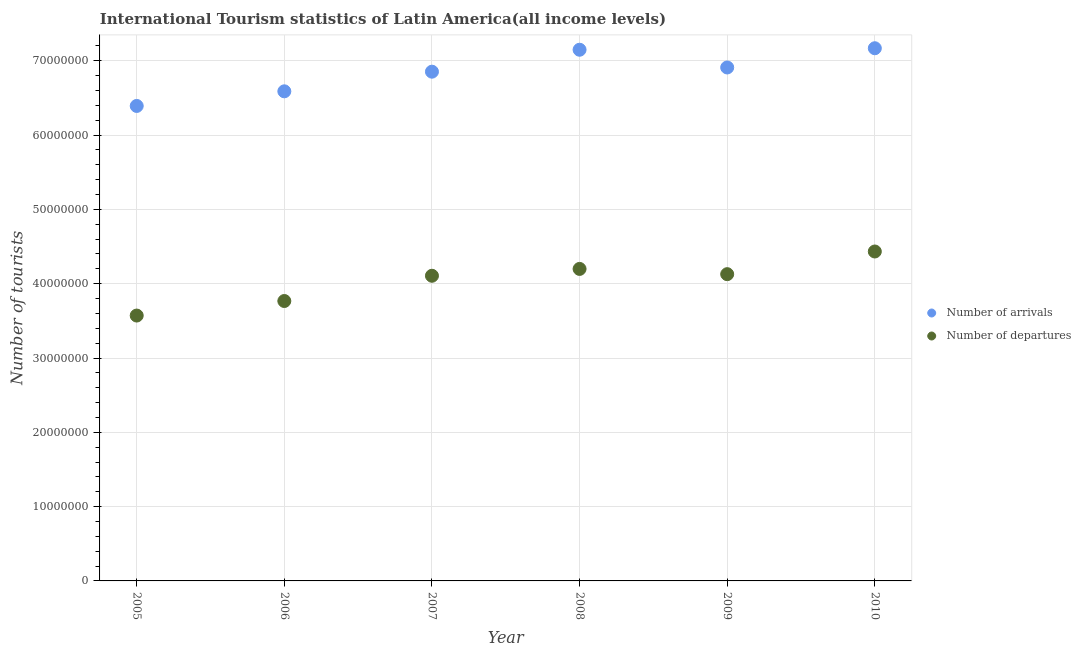How many different coloured dotlines are there?
Keep it short and to the point. 2. What is the number of tourist arrivals in 2009?
Give a very brief answer. 6.91e+07. Across all years, what is the maximum number of tourist departures?
Your answer should be very brief. 4.43e+07. Across all years, what is the minimum number of tourist arrivals?
Your answer should be very brief. 6.39e+07. What is the total number of tourist departures in the graph?
Make the answer very short. 2.42e+08. What is the difference between the number of tourist departures in 2009 and that in 2010?
Make the answer very short. -3.05e+06. What is the difference between the number of tourist departures in 2007 and the number of tourist arrivals in 2008?
Ensure brevity in your answer.  -3.04e+07. What is the average number of tourist departures per year?
Your response must be concise. 4.03e+07. In the year 2005, what is the difference between the number of tourist departures and number of tourist arrivals?
Keep it short and to the point. -2.82e+07. What is the ratio of the number of tourist arrivals in 2006 to that in 2010?
Give a very brief answer. 0.92. Is the number of tourist departures in 2007 less than that in 2008?
Offer a terse response. Yes. Is the difference between the number of tourist departures in 2007 and 2010 greater than the difference between the number of tourist arrivals in 2007 and 2010?
Give a very brief answer. No. What is the difference between the highest and the second highest number of tourist departures?
Keep it short and to the point. 2.34e+06. What is the difference between the highest and the lowest number of tourist arrivals?
Provide a short and direct response. 7.77e+06. In how many years, is the number of tourist arrivals greater than the average number of tourist arrivals taken over all years?
Ensure brevity in your answer.  4. Is the number of tourist arrivals strictly greater than the number of tourist departures over the years?
Provide a succinct answer. Yes. How many years are there in the graph?
Offer a terse response. 6. What is the difference between two consecutive major ticks on the Y-axis?
Offer a terse response. 1.00e+07. Does the graph contain any zero values?
Provide a short and direct response. No. Does the graph contain grids?
Your answer should be compact. Yes. Where does the legend appear in the graph?
Keep it short and to the point. Center right. What is the title of the graph?
Your response must be concise. International Tourism statistics of Latin America(all income levels). Does "Nitrous oxide emissions" appear as one of the legend labels in the graph?
Provide a short and direct response. No. What is the label or title of the Y-axis?
Your response must be concise. Number of tourists. What is the Number of tourists in Number of arrivals in 2005?
Ensure brevity in your answer.  6.39e+07. What is the Number of tourists in Number of departures in 2005?
Your response must be concise. 3.57e+07. What is the Number of tourists in Number of arrivals in 2006?
Your answer should be very brief. 6.59e+07. What is the Number of tourists in Number of departures in 2006?
Make the answer very short. 3.77e+07. What is the Number of tourists of Number of arrivals in 2007?
Offer a very short reply. 6.85e+07. What is the Number of tourists in Number of departures in 2007?
Provide a succinct answer. 4.11e+07. What is the Number of tourists in Number of arrivals in 2008?
Your answer should be very brief. 7.15e+07. What is the Number of tourists in Number of departures in 2008?
Your response must be concise. 4.20e+07. What is the Number of tourists of Number of arrivals in 2009?
Give a very brief answer. 6.91e+07. What is the Number of tourists in Number of departures in 2009?
Ensure brevity in your answer.  4.13e+07. What is the Number of tourists in Number of arrivals in 2010?
Your answer should be compact. 7.17e+07. What is the Number of tourists in Number of departures in 2010?
Offer a terse response. 4.43e+07. Across all years, what is the maximum Number of tourists in Number of arrivals?
Give a very brief answer. 7.17e+07. Across all years, what is the maximum Number of tourists in Number of departures?
Provide a succinct answer. 4.43e+07. Across all years, what is the minimum Number of tourists in Number of arrivals?
Your response must be concise. 6.39e+07. Across all years, what is the minimum Number of tourists in Number of departures?
Your answer should be very brief. 3.57e+07. What is the total Number of tourists of Number of arrivals in the graph?
Provide a succinct answer. 4.11e+08. What is the total Number of tourists of Number of departures in the graph?
Your answer should be very brief. 2.42e+08. What is the difference between the Number of tourists in Number of arrivals in 2005 and that in 2006?
Offer a very short reply. -1.97e+06. What is the difference between the Number of tourists of Number of departures in 2005 and that in 2006?
Keep it short and to the point. -1.96e+06. What is the difference between the Number of tourists of Number of arrivals in 2005 and that in 2007?
Offer a very short reply. -4.61e+06. What is the difference between the Number of tourists in Number of departures in 2005 and that in 2007?
Your answer should be compact. -5.35e+06. What is the difference between the Number of tourists in Number of arrivals in 2005 and that in 2008?
Provide a succinct answer. -7.56e+06. What is the difference between the Number of tourists in Number of departures in 2005 and that in 2008?
Offer a terse response. -6.28e+06. What is the difference between the Number of tourists in Number of arrivals in 2005 and that in 2009?
Your answer should be compact. -5.18e+06. What is the difference between the Number of tourists of Number of departures in 2005 and that in 2009?
Provide a short and direct response. -5.57e+06. What is the difference between the Number of tourists of Number of arrivals in 2005 and that in 2010?
Your answer should be very brief. -7.77e+06. What is the difference between the Number of tourists of Number of departures in 2005 and that in 2010?
Give a very brief answer. -8.62e+06. What is the difference between the Number of tourists in Number of arrivals in 2006 and that in 2007?
Offer a very short reply. -2.64e+06. What is the difference between the Number of tourists of Number of departures in 2006 and that in 2007?
Provide a short and direct response. -3.40e+06. What is the difference between the Number of tourists of Number of arrivals in 2006 and that in 2008?
Your response must be concise. -5.59e+06. What is the difference between the Number of tourists in Number of departures in 2006 and that in 2008?
Your answer should be very brief. -4.32e+06. What is the difference between the Number of tourists in Number of arrivals in 2006 and that in 2009?
Your answer should be very brief. -3.21e+06. What is the difference between the Number of tourists in Number of departures in 2006 and that in 2009?
Provide a succinct answer. -3.61e+06. What is the difference between the Number of tourists of Number of arrivals in 2006 and that in 2010?
Your answer should be compact. -5.80e+06. What is the difference between the Number of tourists in Number of departures in 2006 and that in 2010?
Your answer should be very brief. -6.66e+06. What is the difference between the Number of tourists of Number of arrivals in 2007 and that in 2008?
Make the answer very short. -2.95e+06. What is the difference between the Number of tourists of Number of departures in 2007 and that in 2008?
Provide a short and direct response. -9.22e+05. What is the difference between the Number of tourists in Number of arrivals in 2007 and that in 2009?
Provide a succinct answer. -5.66e+05. What is the difference between the Number of tourists of Number of departures in 2007 and that in 2009?
Ensure brevity in your answer.  -2.15e+05. What is the difference between the Number of tourists of Number of arrivals in 2007 and that in 2010?
Provide a succinct answer. -3.15e+06. What is the difference between the Number of tourists of Number of departures in 2007 and that in 2010?
Provide a short and direct response. -3.27e+06. What is the difference between the Number of tourists in Number of arrivals in 2008 and that in 2009?
Make the answer very short. 2.39e+06. What is the difference between the Number of tourists of Number of departures in 2008 and that in 2009?
Keep it short and to the point. 7.06e+05. What is the difference between the Number of tourists in Number of arrivals in 2008 and that in 2010?
Your response must be concise. -2.02e+05. What is the difference between the Number of tourists in Number of departures in 2008 and that in 2010?
Your answer should be very brief. -2.34e+06. What is the difference between the Number of tourists of Number of arrivals in 2009 and that in 2010?
Offer a very short reply. -2.59e+06. What is the difference between the Number of tourists in Number of departures in 2009 and that in 2010?
Keep it short and to the point. -3.05e+06. What is the difference between the Number of tourists of Number of arrivals in 2005 and the Number of tourists of Number of departures in 2006?
Offer a terse response. 2.63e+07. What is the difference between the Number of tourists in Number of arrivals in 2005 and the Number of tourists in Number of departures in 2007?
Give a very brief answer. 2.29e+07. What is the difference between the Number of tourists in Number of arrivals in 2005 and the Number of tourists in Number of departures in 2008?
Offer a terse response. 2.19e+07. What is the difference between the Number of tourists in Number of arrivals in 2005 and the Number of tourists in Number of departures in 2009?
Ensure brevity in your answer.  2.26e+07. What is the difference between the Number of tourists of Number of arrivals in 2005 and the Number of tourists of Number of departures in 2010?
Your answer should be very brief. 1.96e+07. What is the difference between the Number of tourists of Number of arrivals in 2006 and the Number of tourists of Number of departures in 2007?
Your answer should be very brief. 2.48e+07. What is the difference between the Number of tourists in Number of arrivals in 2006 and the Number of tourists in Number of departures in 2008?
Your response must be concise. 2.39e+07. What is the difference between the Number of tourists in Number of arrivals in 2006 and the Number of tourists in Number of departures in 2009?
Make the answer very short. 2.46e+07. What is the difference between the Number of tourists in Number of arrivals in 2006 and the Number of tourists in Number of departures in 2010?
Ensure brevity in your answer.  2.16e+07. What is the difference between the Number of tourists of Number of arrivals in 2007 and the Number of tourists of Number of departures in 2008?
Give a very brief answer. 2.65e+07. What is the difference between the Number of tourists of Number of arrivals in 2007 and the Number of tourists of Number of departures in 2009?
Your answer should be very brief. 2.73e+07. What is the difference between the Number of tourists in Number of arrivals in 2007 and the Number of tourists in Number of departures in 2010?
Keep it short and to the point. 2.42e+07. What is the difference between the Number of tourists of Number of arrivals in 2008 and the Number of tourists of Number of departures in 2009?
Ensure brevity in your answer.  3.02e+07. What is the difference between the Number of tourists in Number of arrivals in 2008 and the Number of tourists in Number of departures in 2010?
Provide a succinct answer. 2.72e+07. What is the difference between the Number of tourists in Number of arrivals in 2009 and the Number of tourists in Number of departures in 2010?
Provide a short and direct response. 2.48e+07. What is the average Number of tourists of Number of arrivals per year?
Offer a very short reply. 6.84e+07. What is the average Number of tourists in Number of departures per year?
Provide a succinct answer. 4.03e+07. In the year 2005, what is the difference between the Number of tourists in Number of arrivals and Number of tourists in Number of departures?
Your answer should be very brief. 2.82e+07. In the year 2006, what is the difference between the Number of tourists of Number of arrivals and Number of tourists of Number of departures?
Your answer should be very brief. 2.82e+07. In the year 2007, what is the difference between the Number of tourists of Number of arrivals and Number of tourists of Number of departures?
Your answer should be compact. 2.75e+07. In the year 2008, what is the difference between the Number of tourists in Number of arrivals and Number of tourists in Number of departures?
Provide a short and direct response. 2.95e+07. In the year 2009, what is the difference between the Number of tourists in Number of arrivals and Number of tourists in Number of departures?
Your response must be concise. 2.78e+07. In the year 2010, what is the difference between the Number of tourists of Number of arrivals and Number of tourists of Number of departures?
Provide a succinct answer. 2.74e+07. What is the ratio of the Number of tourists in Number of arrivals in 2005 to that in 2006?
Make the answer very short. 0.97. What is the ratio of the Number of tourists in Number of departures in 2005 to that in 2006?
Give a very brief answer. 0.95. What is the ratio of the Number of tourists in Number of arrivals in 2005 to that in 2007?
Offer a terse response. 0.93. What is the ratio of the Number of tourists in Number of departures in 2005 to that in 2007?
Ensure brevity in your answer.  0.87. What is the ratio of the Number of tourists in Number of arrivals in 2005 to that in 2008?
Keep it short and to the point. 0.89. What is the ratio of the Number of tourists in Number of departures in 2005 to that in 2008?
Make the answer very short. 0.85. What is the ratio of the Number of tourists of Number of arrivals in 2005 to that in 2009?
Your answer should be very brief. 0.93. What is the ratio of the Number of tourists in Number of departures in 2005 to that in 2009?
Make the answer very short. 0.87. What is the ratio of the Number of tourists in Number of arrivals in 2005 to that in 2010?
Your answer should be compact. 0.89. What is the ratio of the Number of tourists of Number of departures in 2005 to that in 2010?
Offer a very short reply. 0.81. What is the ratio of the Number of tourists of Number of arrivals in 2006 to that in 2007?
Offer a terse response. 0.96. What is the ratio of the Number of tourists of Number of departures in 2006 to that in 2007?
Give a very brief answer. 0.92. What is the ratio of the Number of tourists in Number of arrivals in 2006 to that in 2008?
Keep it short and to the point. 0.92. What is the ratio of the Number of tourists in Number of departures in 2006 to that in 2008?
Provide a succinct answer. 0.9. What is the ratio of the Number of tourists of Number of arrivals in 2006 to that in 2009?
Your response must be concise. 0.95. What is the ratio of the Number of tourists in Number of departures in 2006 to that in 2009?
Give a very brief answer. 0.91. What is the ratio of the Number of tourists in Number of arrivals in 2006 to that in 2010?
Ensure brevity in your answer.  0.92. What is the ratio of the Number of tourists in Number of departures in 2006 to that in 2010?
Make the answer very short. 0.85. What is the ratio of the Number of tourists in Number of arrivals in 2007 to that in 2008?
Your answer should be compact. 0.96. What is the ratio of the Number of tourists of Number of departures in 2007 to that in 2008?
Keep it short and to the point. 0.98. What is the ratio of the Number of tourists of Number of arrivals in 2007 to that in 2009?
Provide a succinct answer. 0.99. What is the ratio of the Number of tourists of Number of departures in 2007 to that in 2009?
Offer a terse response. 0.99. What is the ratio of the Number of tourists of Number of arrivals in 2007 to that in 2010?
Your answer should be very brief. 0.96. What is the ratio of the Number of tourists in Number of departures in 2007 to that in 2010?
Offer a very short reply. 0.93. What is the ratio of the Number of tourists of Number of arrivals in 2008 to that in 2009?
Give a very brief answer. 1.03. What is the ratio of the Number of tourists of Number of departures in 2008 to that in 2009?
Give a very brief answer. 1.02. What is the ratio of the Number of tourists of Number of departures in 2008 to that in 2010?
Provide a short and direct response. 0.95. What is the ratio of the Number of tourists in Number of arrivals in 2009 to that in 2010?
Keep it short and to the point. 0.96. What is the ratio of the Number of tourists of Number of departures in 2009 to that in 2010?
Offer a terse response. 0.93. What is the difference between the highest and the second highest Number of tourists of Number of arrivals?
Ensure brevity in your answer.  2.02e+05. What is the difference between the highest and the second highest Number of tourists in Number of departures?
Your answer should be very brief. 2.34e+06. What is the difference between the highest and the lowest Number of tourists of Number of arrivals?
Offer a terse response. 7.77e+06. What is the difference between the highest and the lowest Number of tourists in Number of departures?
Offer a terse response. 8.62e+06. 